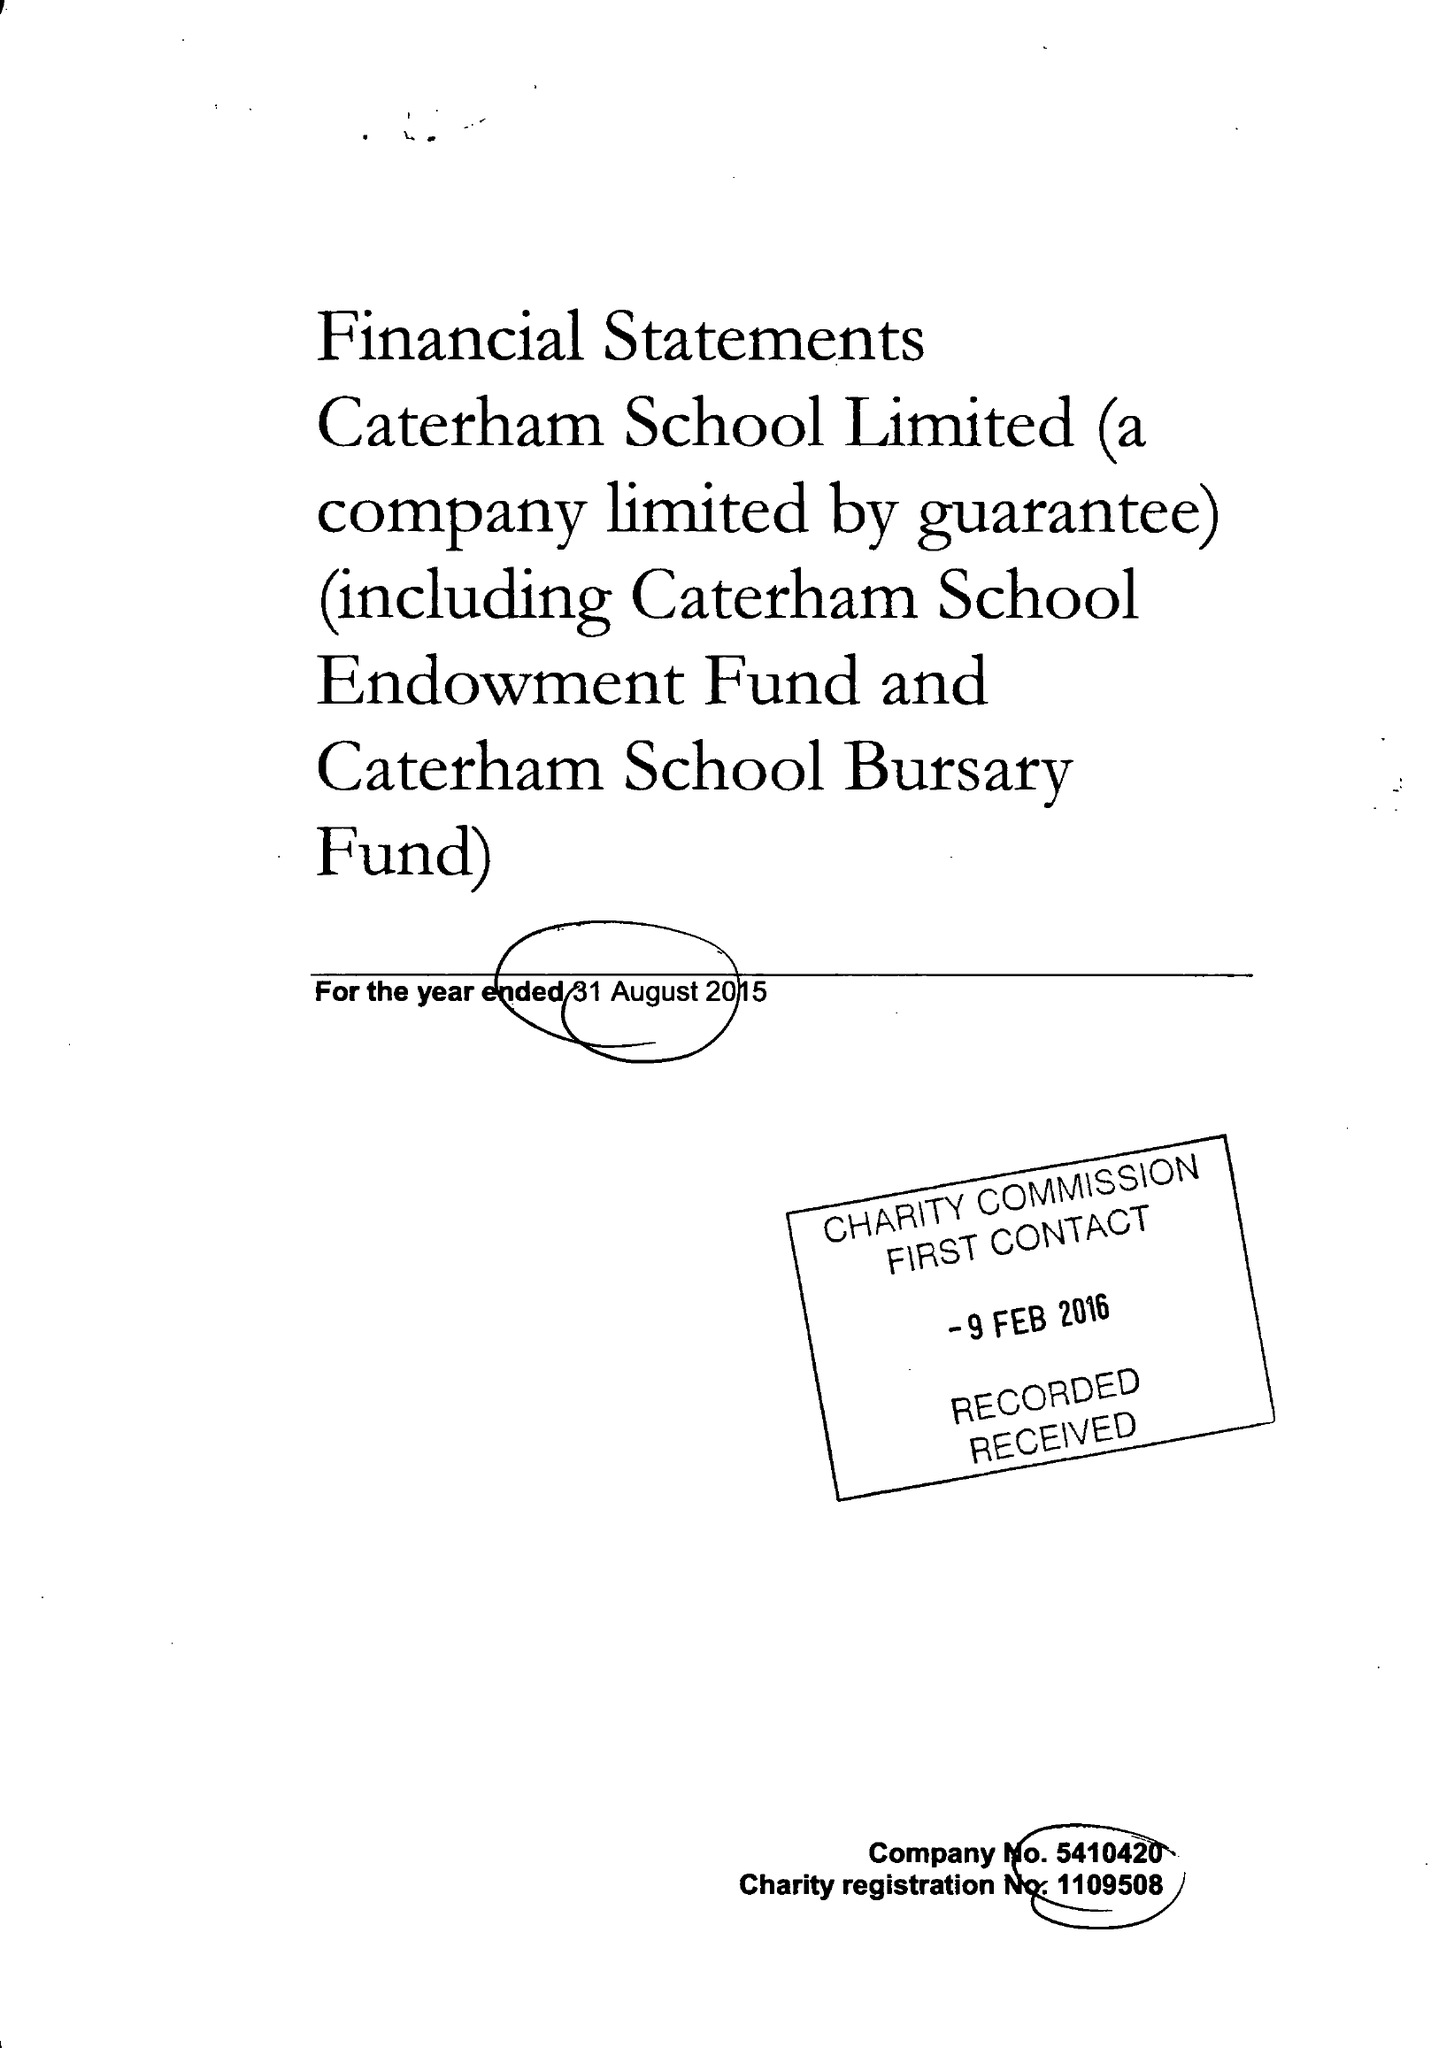What is the value for the charity_name?
Answer the question using a single word or phrase. Caterham School Ltd. 